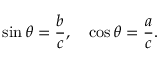<formula> <loc_0><loc_0><loc_500><loc_500>\sin \theta = { \frac { b } { c } } , \quad \cos \theta = { \frac { a } { c } } .</formula> 